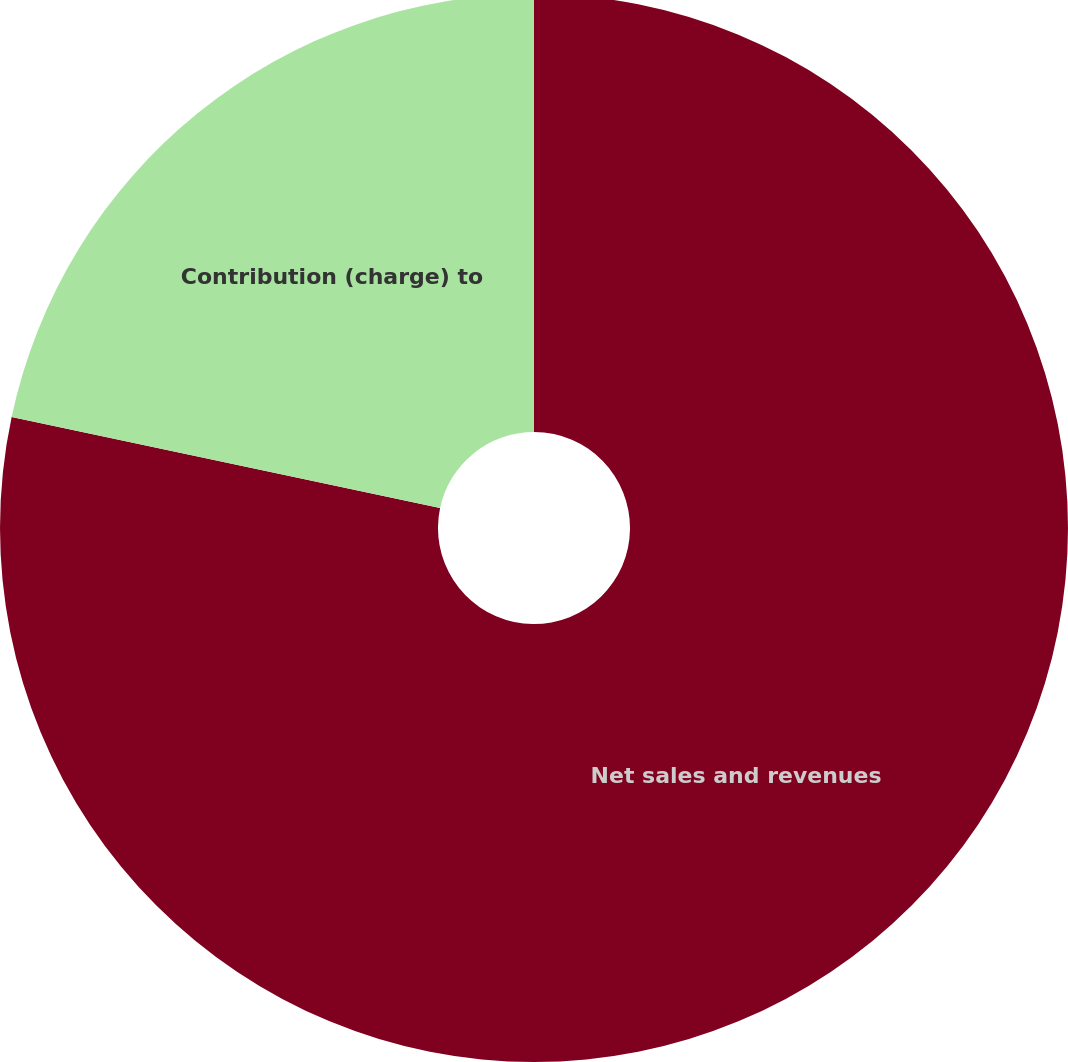Convert chart to OTSL. <chart><loc_0><loc_0><loc_500><loc_500><pie_chart><fcel>Net sales and revenues<fcel>Contribution (charge) to<nl><fcel>78.33%<fcel>21.67%<nl></chart> 